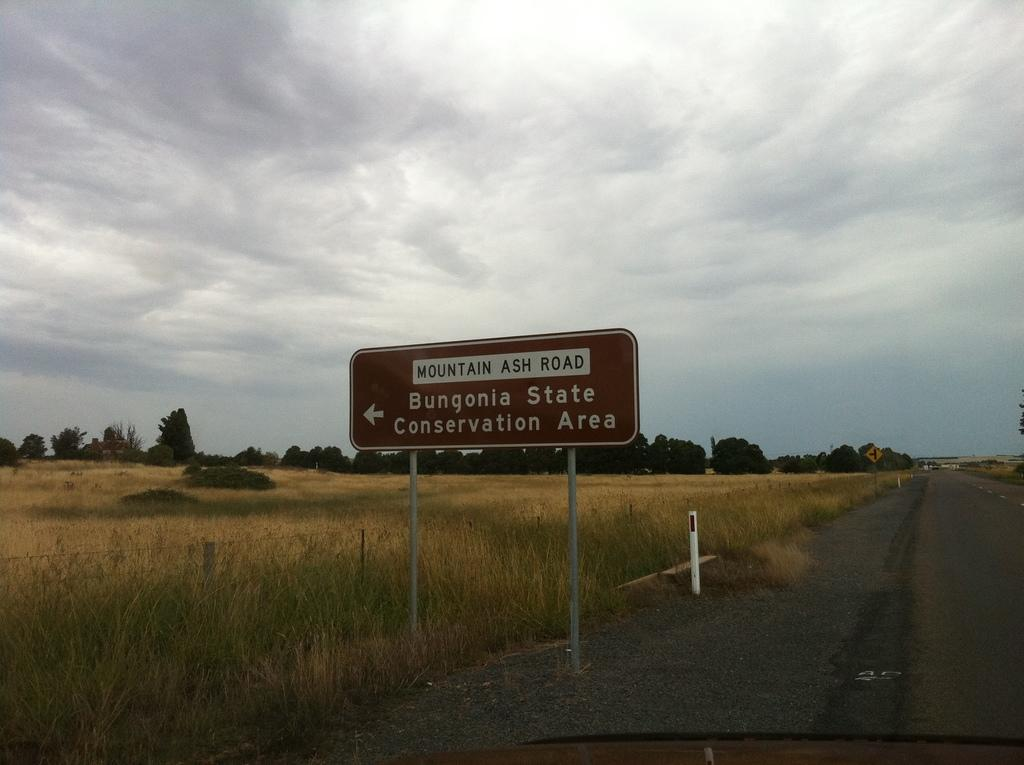<image>
Give a short and clear explanation of the subsequent image. A road with a brown sign that is indicating where Bungonia State Conservation Area is. 